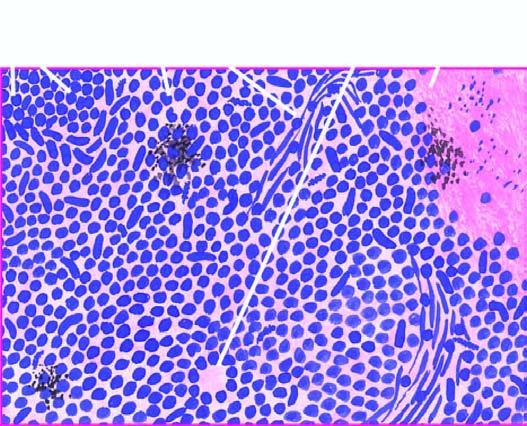how are the individual tumour cells?
Answer the question using a single word or phrase. Small 